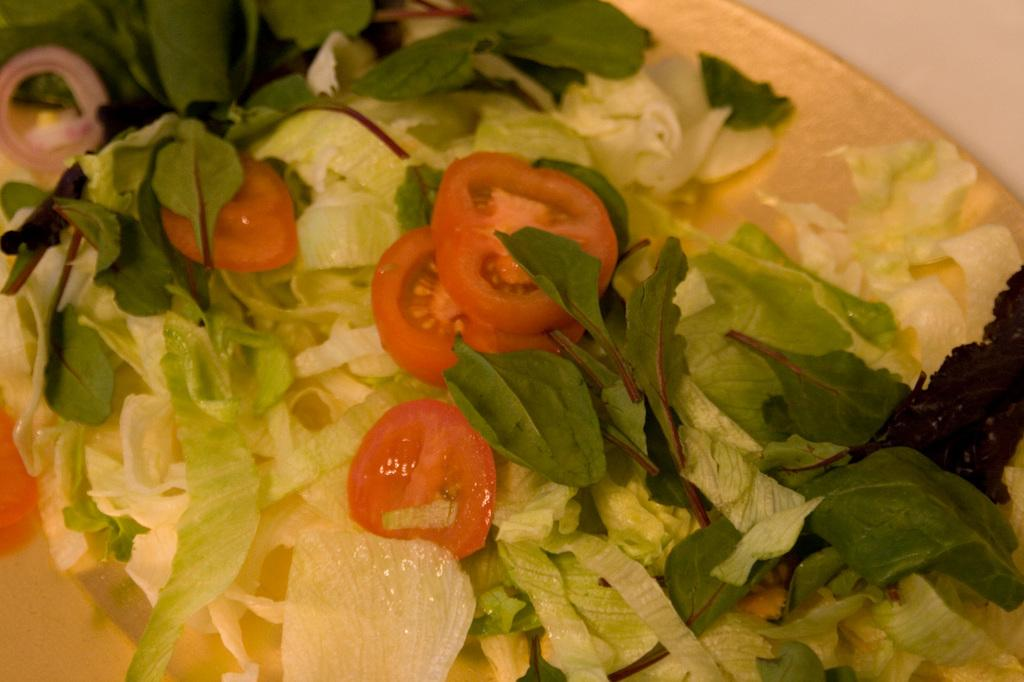What is the main subject of the image? There is a food item in the image. Can you describe the surface on which the food item is placed? The food item is placed on a white surface. What type of insurance policy is mentioned in the image? There is no mention of an insurance policy in the image; it only features a food item placed on a white surface. 